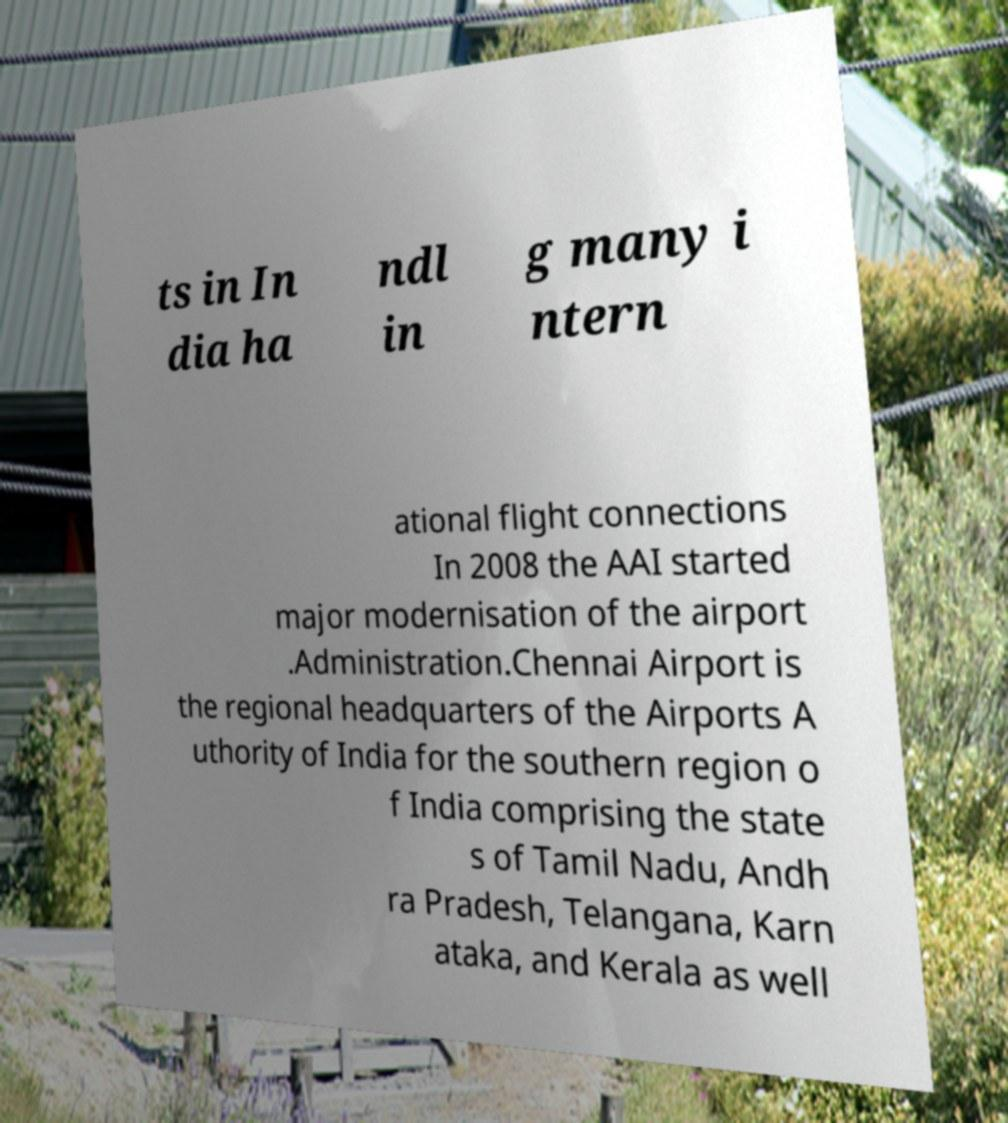Can you read and provide the text displayed in the image?This photo seems to have some interesting text. Can you extract and type it out for me? ts in In dia ha ndl in g many i ntern ational flight connections In 2008 the AAI started major modernisation of the airport .Administration.Chennai Airport is the regional headquarters of the Airports A uthority of India for the southern region o f India comprising the state s of Tamil Nadu, Andh ra Pradesh, Telangana, Karn ataka, and Kerala as well 